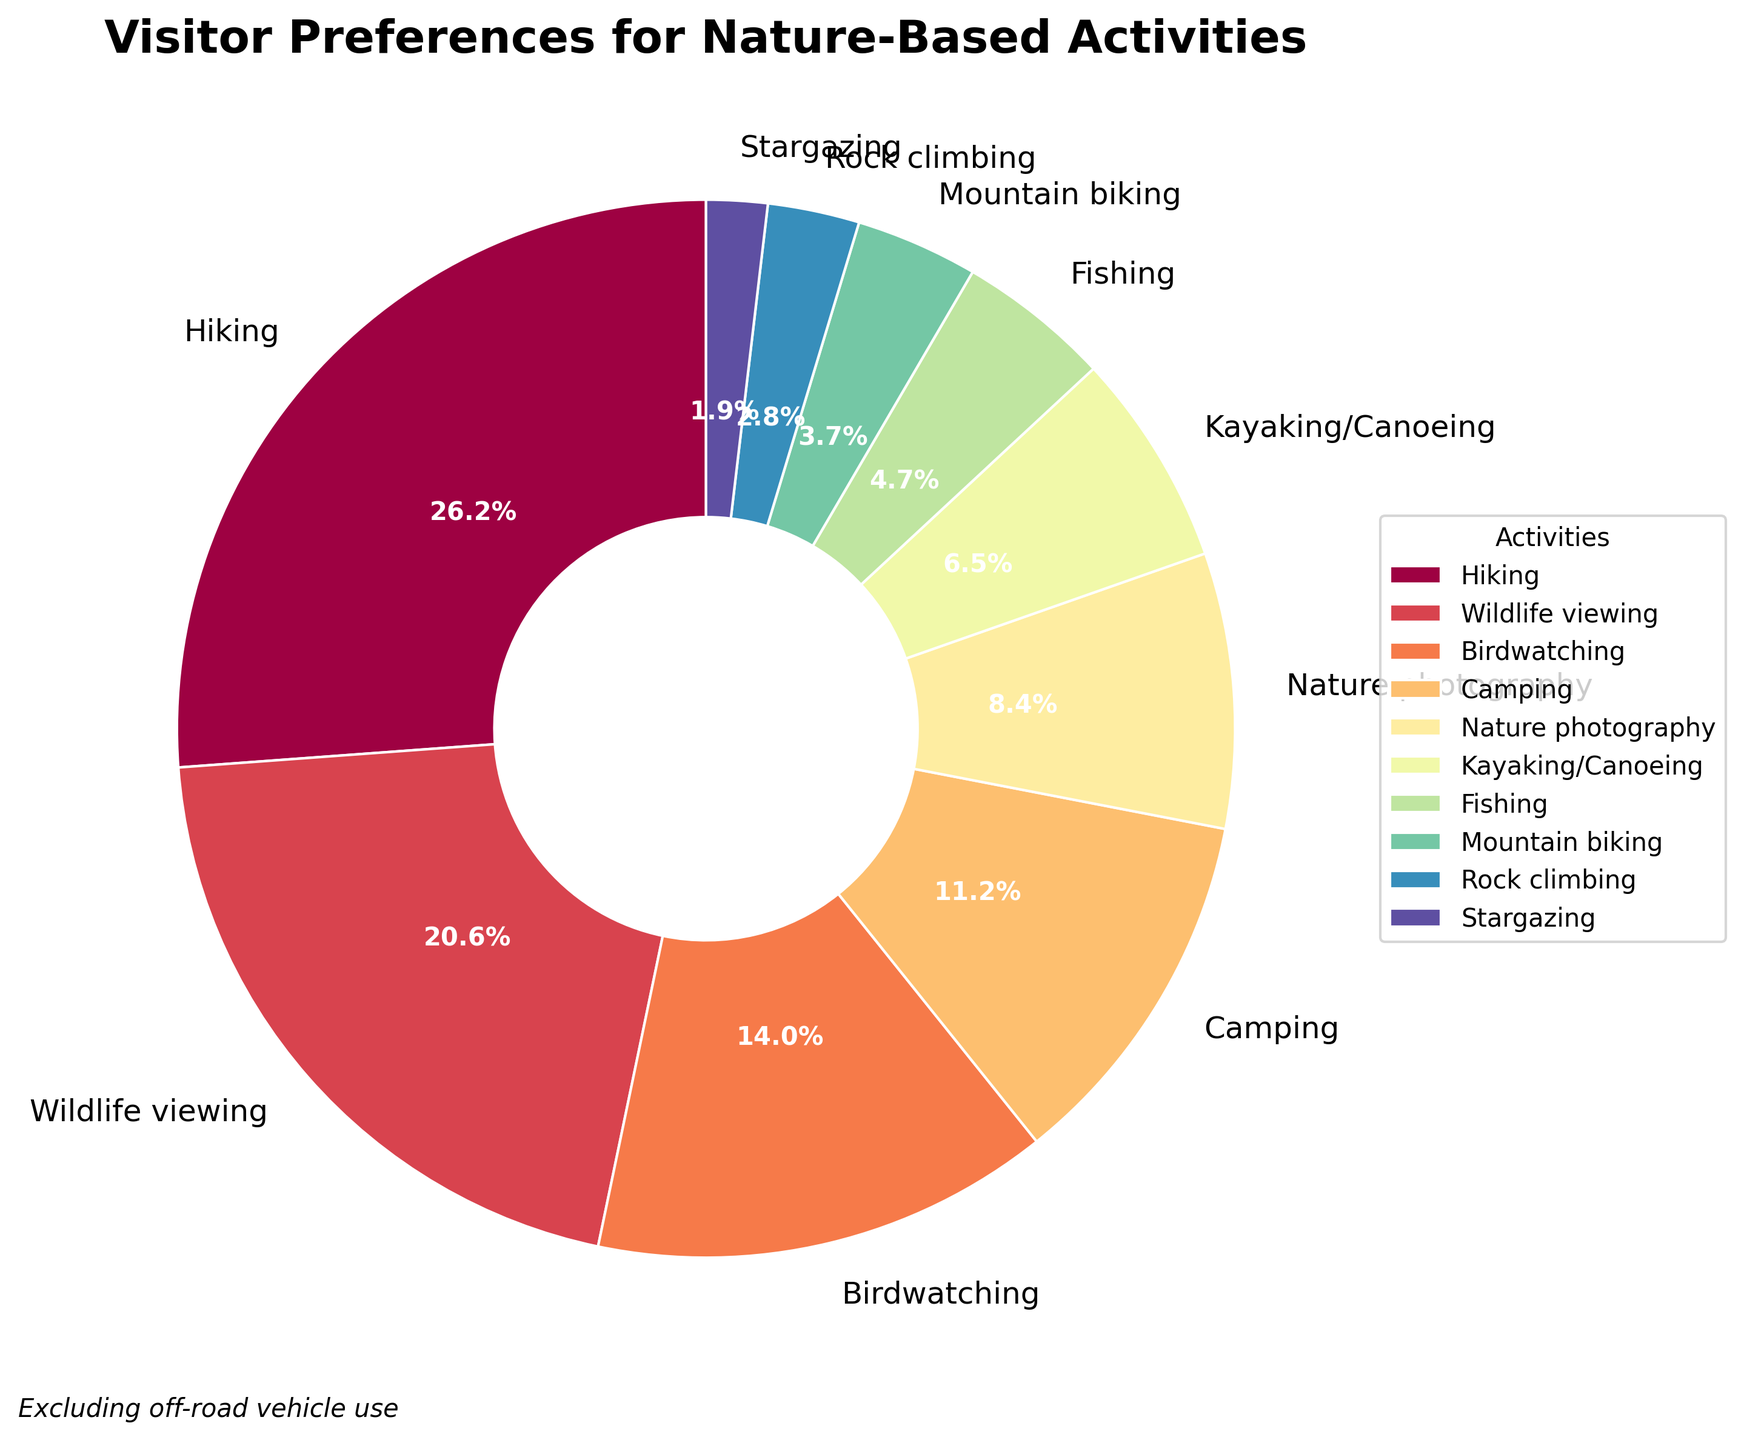What activity has the highest percentage of visitor preference? The figure shows the percentages for each activity in a pie chart. The slice for "Hiking" is the largest, labeled with 28%.
Answer: Hiking Which activity has the lowest percentage of visitor preference? The figure shows a small slice labeled "Stargazing" with a percentage of 2%.
Answer: Stargazing How much more popular is Hiking compared to Mountain biking? Hiking has a preference of 28%, and Mountain biking has 4%. The difference between them is 28% - 4% = 24%.
Answer: 24% What is the combined preference percentage for Wildlife viewing and Birdwatching? Wildlife viewing is 22% and Birdwatching is 15%. Their combined preference is 22% + 15% = 37%.
Answer: 37% Which activities have a preference percentage lower than 10%? The pie chart shows that Nature photography (9%), Kayaking/Canoeing (7%), Fishing (5%), Mountain biking (4%), Rock climbing (3%), and Stargazing (2%) have percentages below 10%.
Answer: Nature photography, Kayaking/Canoeing, Fishing, Mountain biking, Rock climbing, Stargazing Are Wildlife viewing and Birdwatching collectively more popular than Hiking alone? Wildlife viewing (22%) + Birdwatching (15%) equals 37%, which is more than Hiking's 28%. So collectively, they are more popular.
Answer: Yes If you were to exclude Hiking and Wildlife viewing, what would be the percentage for the remaining activities? Exclude Hiking (28%) and Wildlife viewing (22%) from the total 100%. The remaining activities' percentage is 100% - 28% - 22% = 50%.
Answer: 50% Which activity has a percentage closest to twice that of Kayaking/Canoeing? Kayaking/Canoeing has 7%, and twice of that is 14%. Birdwatching is the closest with 15%.
Answer: Birdwatching 